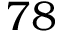Convert formula to latex. <formula><loc_0><loc_0><loc_500><loc_500>7 8</formula> 